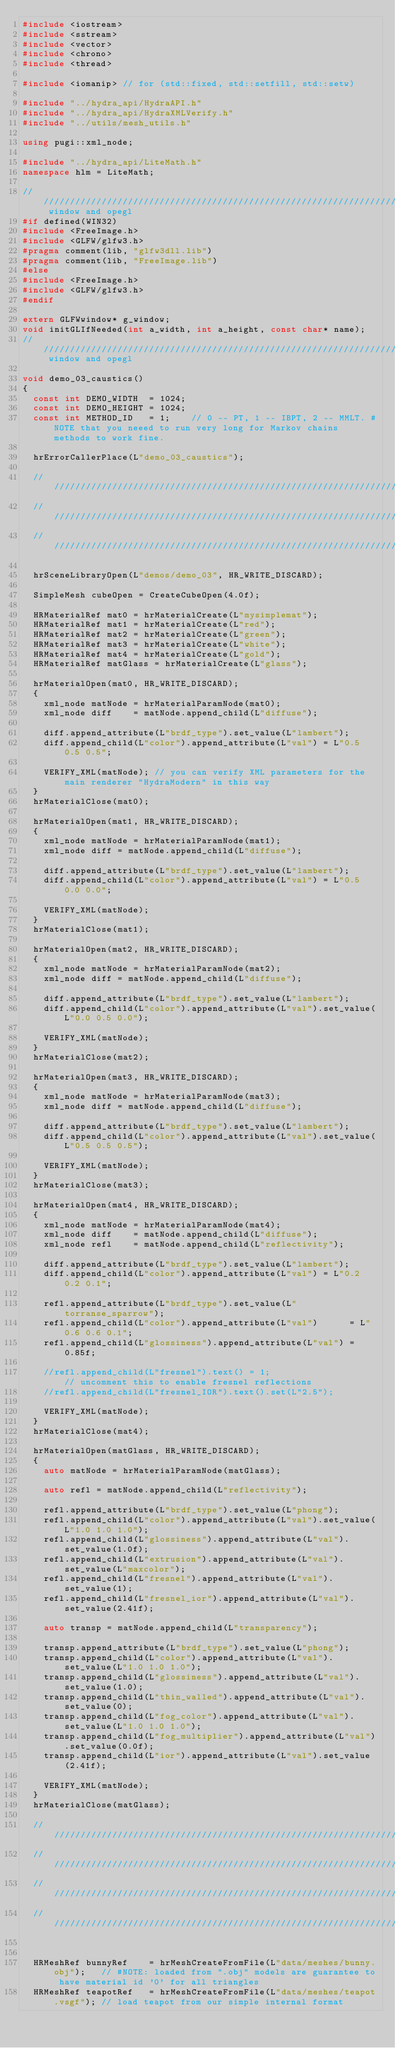Convert code to text. <code><loc_0><loc_0><loc_500><loc_500><_C++_>#include <iostream>
#include <sstream>
#include <vector>
#include <chrono>
#include <thread>

#include <iomanip> // for (std::fixed, std::setfill, std::setw)

#include "../hydra_api/HydraAPI.h"
#include "../hydra_api/HydraXMLVerify.h"
#include "../utils/mesh_utils.h"

using pugi::xml_node;

#include "../hydra_api/LiteMath.h"
namespace hlm = LiteMath;

///////////////////////////////////////////////////////////////////////// window and opegl
#if defined(WIN32)
#include <FreeImage.h>
#include <GLFW/glfw3.h>
#pragma comment(lib, "glfw3dll.lib")
#pragma comment(lib, "FreeImage.lib")
#else
#include <FreeImage.h>
#include <GLFW/glfw3.h>
#endif

extern GLFWwindow* g_window;
void initGLIfNeeded(int a_width, int a_height, const char* name);
///////////////////////////////////////////////////////////////////////// window and opegl

void demo_03_caustics()
{
  const int DEMO_WIDTH  = 1024;
  const int DEMO_HEIGHT = 1024;
  const int METHOD_ID   = 1;    // 0 -- PT, 1 -- IBPT, 2 -- MMLT. #NOTE that you neeed to run very long for Markov chains methods to work fine.
  
  hrErrorCallerPlace(L"demo_03_caustics");
  
  ///////////////////////////////////////////////////////////////////////////////////////////////////////////////////////////////////
  ///////////////////////////////////////////////////////////////////////////////////////////////////////////////////////////////////
  ///////////////////////////////////////////////////////////////////////////////////////////////////////////////////////////////////
  
  hrSceneLibraryOpen(L"demos/demo_03", HR_WRITE_DISCARD);
  
  SimpleMesh cubeOpen = CreateCubeOpen(4.0f);
  
  HRMaterialRef mat0 = hrMaterialCreate(L"mysimplemat");
  HRMaterialRef mat1 = hrMaterialCreate(L"red");
  HRMaterialRef mat2 = hrMaterialCreate(L"green");
  HRMaterialRef mat3 = hrMaterialCreate(L"white");
  HRMaterialRef mat4 = hrMaterialCreate(L"gold");
  HRMaterialRef matGlass = hrMaterialCreate(L"glass");
  
  hrMaterialOpen(mat0, HR_WRITE_DISCARD);
  {
    xml_node matNode = hrMaterialParamNode(mat0);
    xml_node diff    = matNode.append_child(L"diffuse");
    
    diff.append_attribute(L"brdf_type").set_value(L"lambert");
    diff.append_child(L"color").append_attribute(L"val") = L"0.5 0.5 0.5";
    
    VERIFY_XML(matNode); // you can verify XML parameters for the main renderer "HydraModern" in this way
  }
  hrMaterialClose(mat0);
  
  hrMaterialOpen(mat1, HR_WRITE_DISCARD);
  {
    xml_node matNode = hrMaterialParamNode(mat1);
    xml_node diff = matNode.append_child(L"diffuse");
    
    diff.append_attribute(L"brdf_type").set_value(L"lambert");
    diff.append_child(L"color").append_attribute(L"val") = L"0.5 0.0 0.0";
    
    VERIFY_XML(matNode);
  }
  hrMaterialClose(mat1);
  
  hrMaterialOpen(mat2, HR_WRITE_DISCARD);
  {
    xml_node matNode = hrMaterialParamNode(mat2);
    xml_node diff = matNode.append_child(L"diffuse");
    
    diff.append_attribute(L"brdf_type").set_value(L"lambert");
    diff.append_child(L"color").append_attribute(L"val").set_value(L"0.0 0.5 0.0");
  
    VERIFY_XML(matNode);
  }
  hrMaterialClose(mat2);
  
  hrMaterialOpen(mat3, HR_WRITE_DISCARD);
  {
    xml_node matNode = hrMaterialParamNode(mat3);
    xml_node diff = matNode.append_child(L"diffuse");
    
    diff.append_attribute(L"brdf_type").set_value(L"lambert");
    diff.append_child(L"color").append_attribute(L"val").set_value(L"0.5 0.5 0.5");
  
    VERIFY_XML(matNode);
  }
  hrMaterialClose(mat3);
  
  hrMaterialOpen(mat4, HR_WRITE_DISCARD);
  {
    xml_node matNode = hrMaterialParamNode(mat4);
    xml_node diff    = matNode.append_child(L"diffuse");
    xml_node refl    = matNode.append_child(L"reflectivity");
    
    diff.append_attribute(L"brdf_type").set_value(L"lambert");
    diff.append_child(L"color").append_attribute(L"val") = L"0.2 0.2 0.1";
    
    refl.append_attribute(L"brdf_type").set_value(L"torranse_sparrow");
    refl.append_child(L"color").append_attribute(L"val")      = L"0.6 0.6 0.1";
    refl.append_child(L"glossiness").append_attribute(L"val") = 0.85f;
  
    //refl.append_child(L"fresnel").text() = 1;                   // uncomment this to enable fresnel reflections
    //refl.append_child(L"fresnel_IOR").text().set(L"2.5");
    
    VERIFY_XML(matNode);
  }
  hrMaterialClose(mat4);
  
  hrMaterialOpen(matGlass, HR_WRITE_DISCARD);
  {
    auto matNode = hrMaterialParamNode(matGlass);
    
    auto refl = matNode.append_child(L"reflectivity");
    
    refl.append_attribute(L"brdf_type").set_value(L"phong");
    refl.append_child(L"color").append_attribute(L"val").set_value(L"1.0 1.0 1.0");
    refl.append_child(L"glossiness").append_attribute(L"val").set_value(1.0f);
    refl.append_child(L"extrusion").append_attribute(L"val").set_value(L"maxcolor");
    refl.append_child(L"fresnel").append_attribute(L"val").set_value(1);
    refl.append_child(L"fresnel_ior").append_attribute(L"val").set_value(2.41f);
    
    auto transp = matNode.append_child(L"transparency");
    
    transp.append_attribute(L"brdf_type").set_value(L"phong");
    transp.append_child(L"color").append_attribute(L"val").set_value(L"1.0 1.0 1.0");
    transp.append_child(L"glossiness").append_attribute(L"val").set_value(1.0);
    transp.append_child(L"thin_walled").append_attribute(L"val").set_value(0);
    transp.append_child(L"fog_color").append_attribute(L"val").set_value(L"1.0 1.0 1.0");
    transp.append_child(L"fog_multiplier").append_attribute(L"val").set_value(0.0f);
    transp.append_child(L"ior").append_attribute(L"val").set_value(2.41f);
    
    VERIFY_XML(matNode);
  }
  hrMaterialClose(matGlass);
  
  /////////////////////////////////////////////////////////////////////////////////////////////////////////////////////////////////////////////////////
  /////////////////////////////////////////////////////////////////////////////////////////////////////////////////////////////////////////////////////
  /////////////////////////////////////////////////////////////////////////////////////////////////////////////////////////////////////////////////////
  /////////////////////////////////////////////////////////////////////////////////////////////////////////////////////////////////////////////////////
  
  
  HRMeshRef bunnyRef    = hrMeshCreateFromFile(L"data/meshes/bunny.obj");   // #NOTE: loaded from ".obj" models are guarantee to have material id '0' for all triangles
  HRMeshRef teapotRef   = hrMeshCreateFromFile(L"data/meshes/teapot.vsgf"); // load teapot from our simple internal format
  </code> 